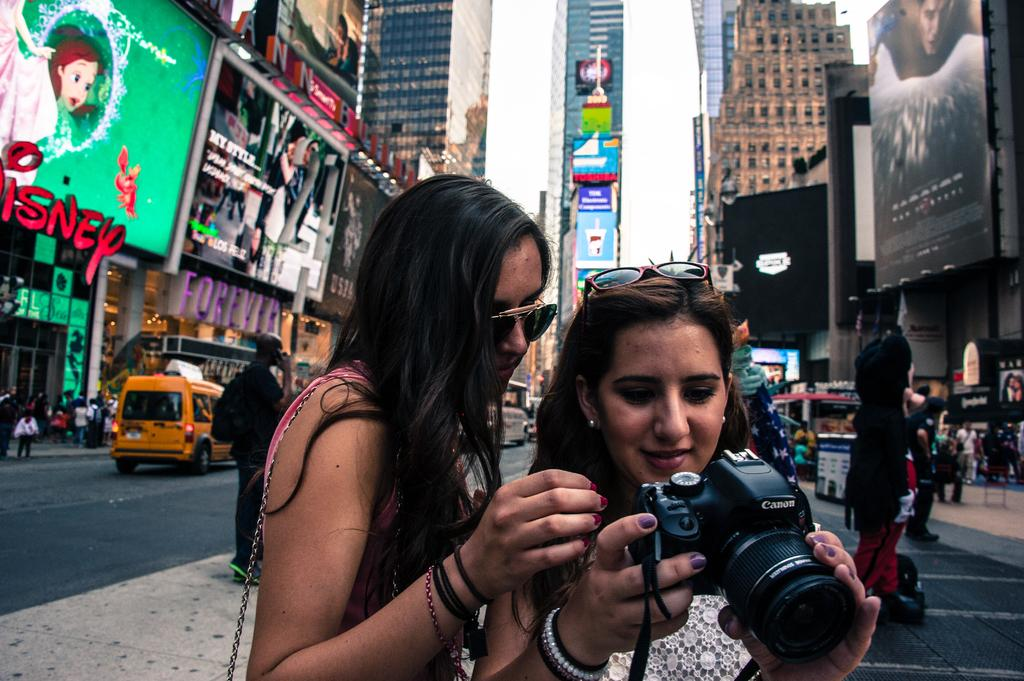<image>
Create a compact narrative representing the image presented. Two girls are looking at the back of a camera that says Canon on it and a Disney sign is in the background. 